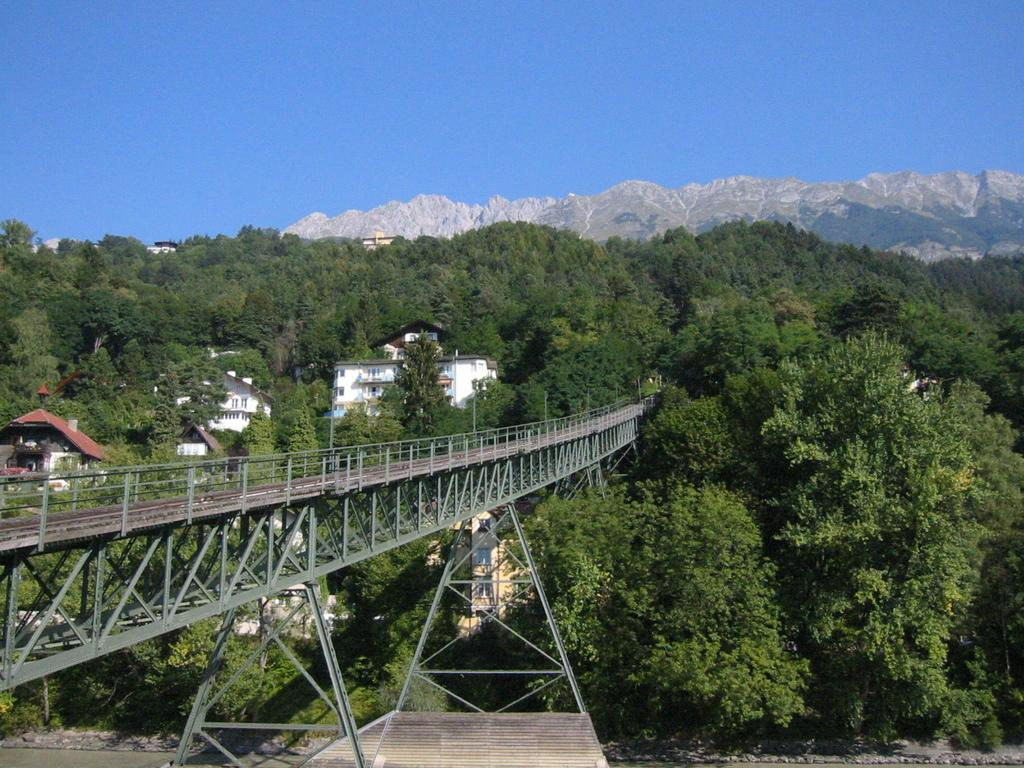What type of structure can be seen in the image? There is a bridge with a fence in the image. What are some features of the buildings in the image? The buildings have windows. What type of vegetation is present in the image? There is a group of trees in the image. What natural landmarks can be seen in the image? The mountains are visible in the image. How would you describe the weather in the image? The sky is cloudy in the image. What type of music can be heard coming from the trees in the image? There is no music coming from the trees in the image; they are simply a group of trees. What type of fork is being used to stir the clouds in the image? There is no fork present in the image, and the clouds are not being stirred. 